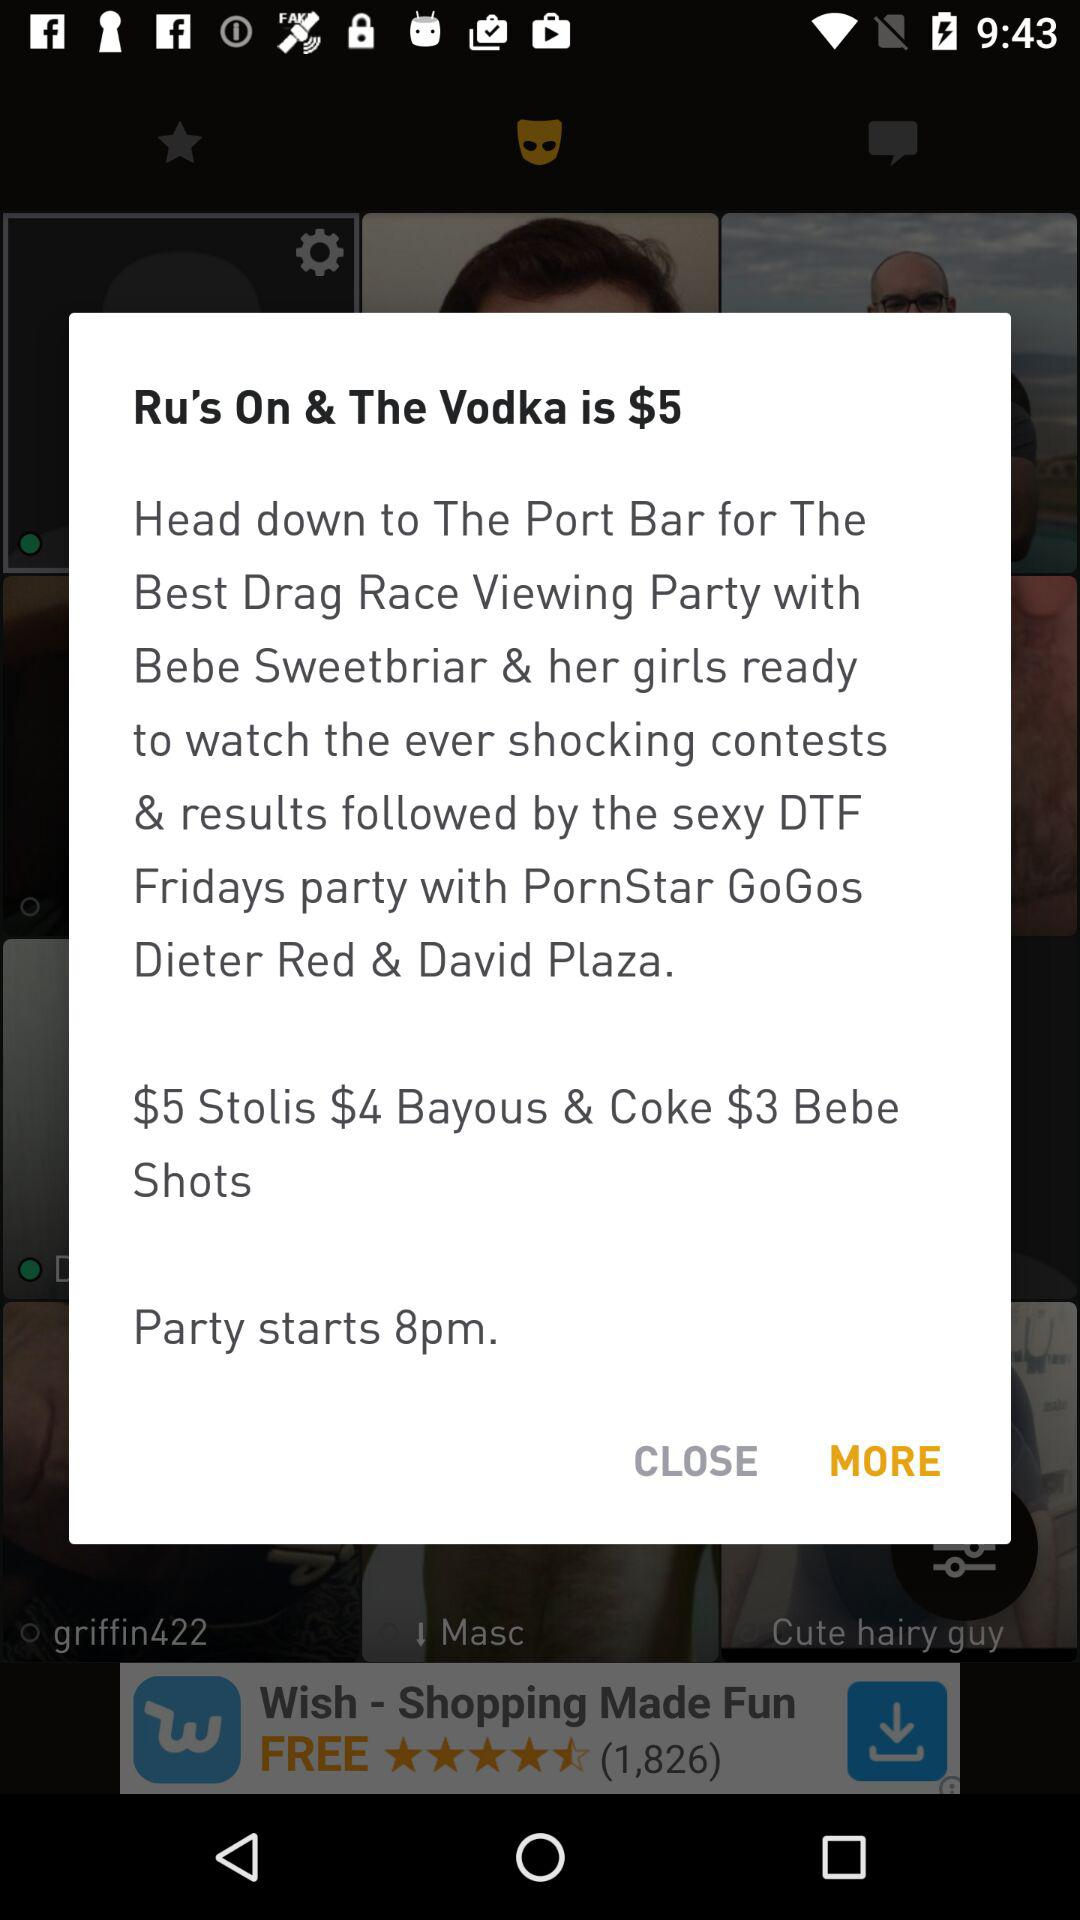What is the price of "Vodka"? The price of "Vodka" is $5. 